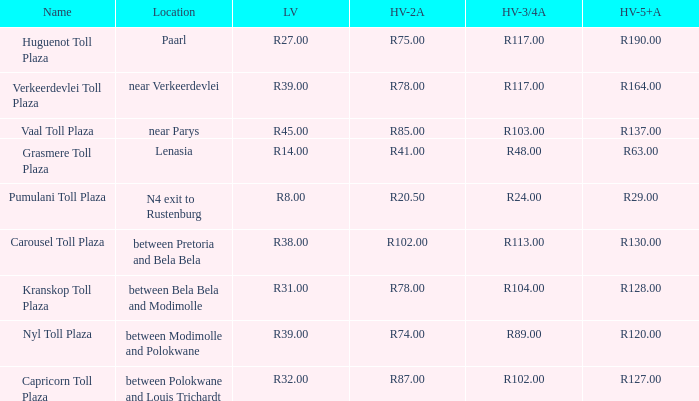What is the toll for light vehicles at the plaza where the toll for heavy vehicles with 2 axles is r87.00? R32.00. 